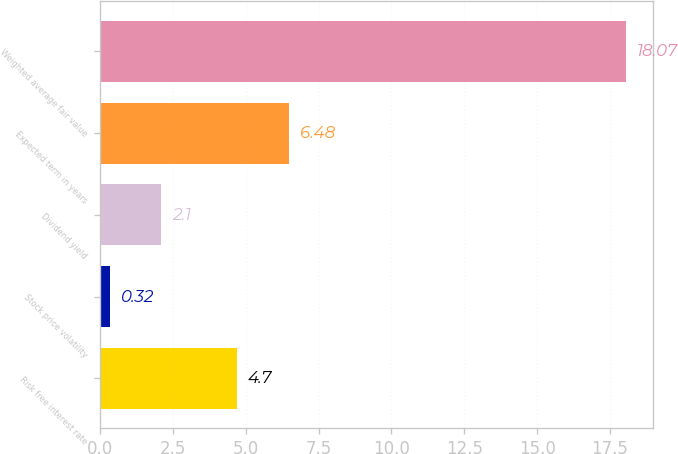<chart> <loc_0><loc_0><loc_500><loc_500><bar_chart><fcel>Risk free interest rate<fcel>Stock price volatility<fcel>Dividend yield<fcel>Expected term in years<fcel>Weighted average fair value<nl><fcel>4.7<fcel>0.32<fcel>2.1<fcel>6.48<fcel>18.07<nl></chart> 